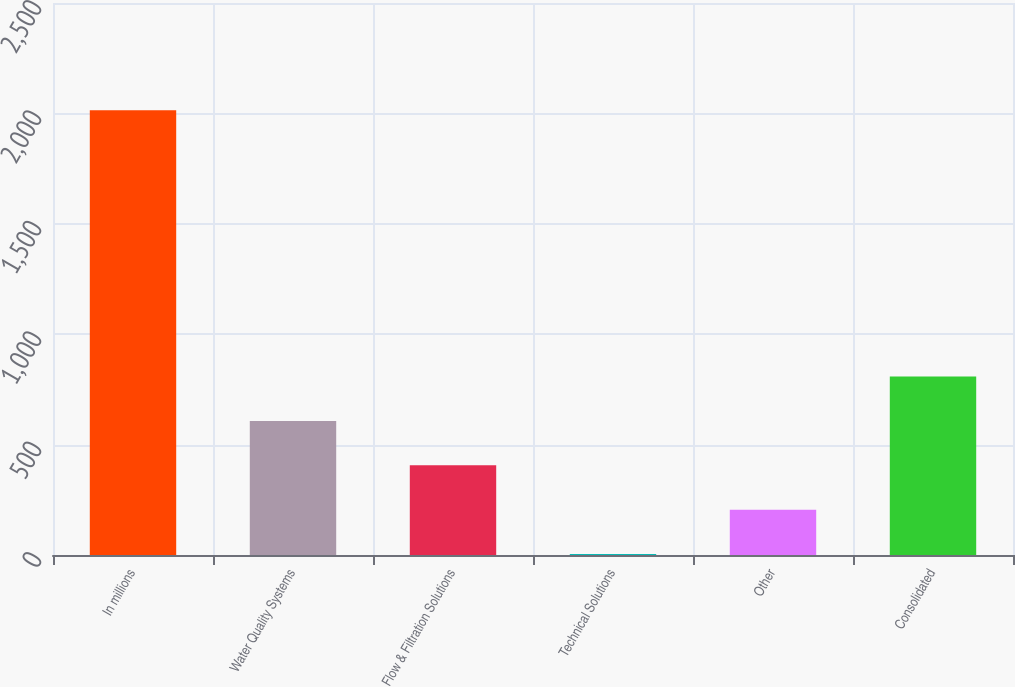<chart> <loc_0><loc_0><loc_500><loc_500><bar_chart><fcel>In millions<fcel>Water Quality Systems<fcel>Flow & Filtration Solutions<fcel>Technical Solutions<fcel>Other<fcel>Consolidated<nl><fcel>2014<fcel>607.21<fcel>406.24<fcel>4.3<fcel>205.27<fcel>808.18<nl></chart> 